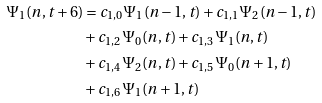Convert formula to latex. <formula><loc_0><loc_0><loc_500><loc_500>\Psi _ { 1 } ( n , t + 6 ) & = c _ { 1 , 0 } \Psi _ { 1 } ( n - 1 , t ) + c _ { 1 , 1 } \Psi _ { 2 } ( n - 1 , t ) \\ & + c _ { 1 , 2 } \Psi _ { 0 } ( n , t ) + c _ { 1 , 3 } \Psi _ { 1 } ( n , t ) \\ & + c _ { 1 , 4 } \Psi _ { 2 } ( n , t ) + c _ { 1 , 5 } \Psi _ { 0 } ( n + 1 , t ) \\ & + c _ { 1 , 6 } \Psi _ { 1 } ( n + 1 , t )</formula> 